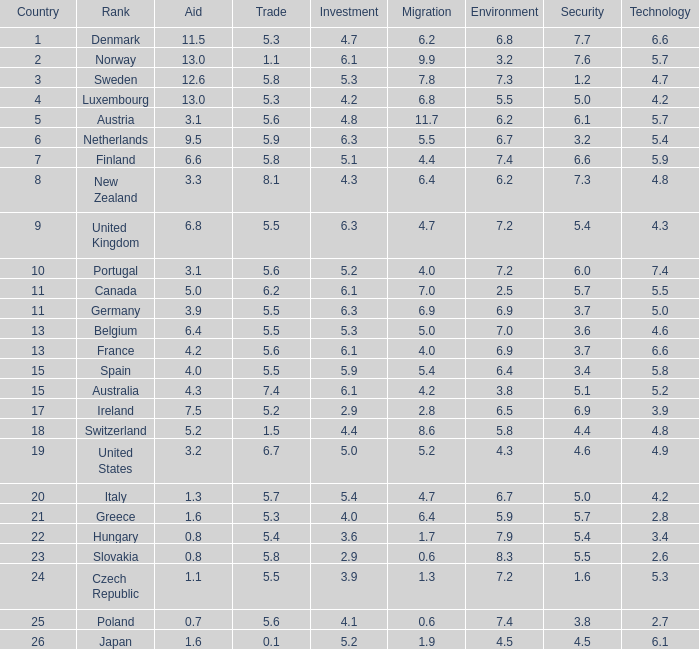Help me parse the entirety of this table. {'header': ['Country', 'Rank', 'Aid', 'Trade', 'Investment', 'Migration', 'Environment', 'Security', 'Technology'], 'rows': [['1', 'Denmark', '11.5', '5.3', '4.7', '6.2', '6.8', '7.7', '6.6'], ['2', 'Norway', '13.0', '1.1', '6.1', '9.9', '3.2', '7.6', '5.7'], ['3', 'Sweden', '12.6', '5.8', '5.3', '7.8', '7.3', '1.2', '4.7'], ['4', 'Luxembourg', '13.0', '5.3', '4.2', '6.8', '5.5', '5.0', '4.2'], ['5', 'Austria', '3.1', '5.6', '4.8', '11.7', '6.2', '6.1', '5.7'], ['6', 'Netherlands', '9.5', '5.9', '6.3', '5.5', '6.7', '3.2', '5.4'], ['7', 'Finland', '6.6', '5.8', '5.1', '4.4', '7.4', '6.6', '5.9'], ['8', 'New Zealand', '3.3', '8.1', '4.3', '6.4', '6.2', '7.3', '4.8'], ['9', 'United Kingdom', '6.8', '5.5', '6.3', '4.7', '7.2', '5.4', '4.3'], ['10', 'Portugal', '3.1', '5.6', '5.2', '4.0', '7.2', '6.0', '7.4'], ['11', 'Canada', '5.0', '6.2', '6.1', '7.0', '2.5', '5.7', '5.5'], ['11', 'Germany', '3.9', '5.5', '6.3', '6.9', '6.9', '3.7', '5.0'], ['13', 'Belgium', '6.4', '5.5', '5.3', '5.0', '7.0', '3.6', '4.6'], ['13', 'France', '4.2', '5.6', '6.1', '4.0', '6.9', '3.7', '6.6'], ['15', 'Spain', '4.0', '5.5', '5.9', '5.4', '6.4', '3.4', '5.8'], ['15', 'Australia', '4.3', '7.4', '6.1', '4.2', '3.8', '5.1', '5.2'], ['17', 'Ireland', '7.5', '5.2', '2.9', '2.8', '6.5', '6.9', '3.9'], ['18', 'Switzerland', '5.2', '1.5', '4.4', '8.6', '5.8', '4.4', '4.8'], ['19', 'United States', '3.2', '6.7', '5.0', '5.2', '4.3', '4.6', '4.9'], ['20', 'Italy', '1.3', '5.7', '5.4', '4.7', '6.7', '5.0', '4.2'], ['21', 'Greece', '1.6', '5.3', '4.0', '6.4', '5.9', '5.7', '2.8'], ['22', 'Hungary', '0.8', '5.4', '3.6', '1.7', '7.9', '5.4', '3.4'], ['23', 'Slovakia', '0.8', '5.8', '2.9', '0.6', '8.3', '5.5', '2.6'], ['24', 'Czech Republic', '1.1', '5.5', '3.9', '1.3', '7.2', '1.6', '5.3'], ['25', 'Poland', '0.7', '5.6', '4.1', '0.6', '7.4', '3.8', '2.7'], ['26', 'Japan', '1.6', '0.1', '5.2', '1.9', '4.5', '4.5', '6.1']]} How many times is denmark ranked in technology? 1.0. 